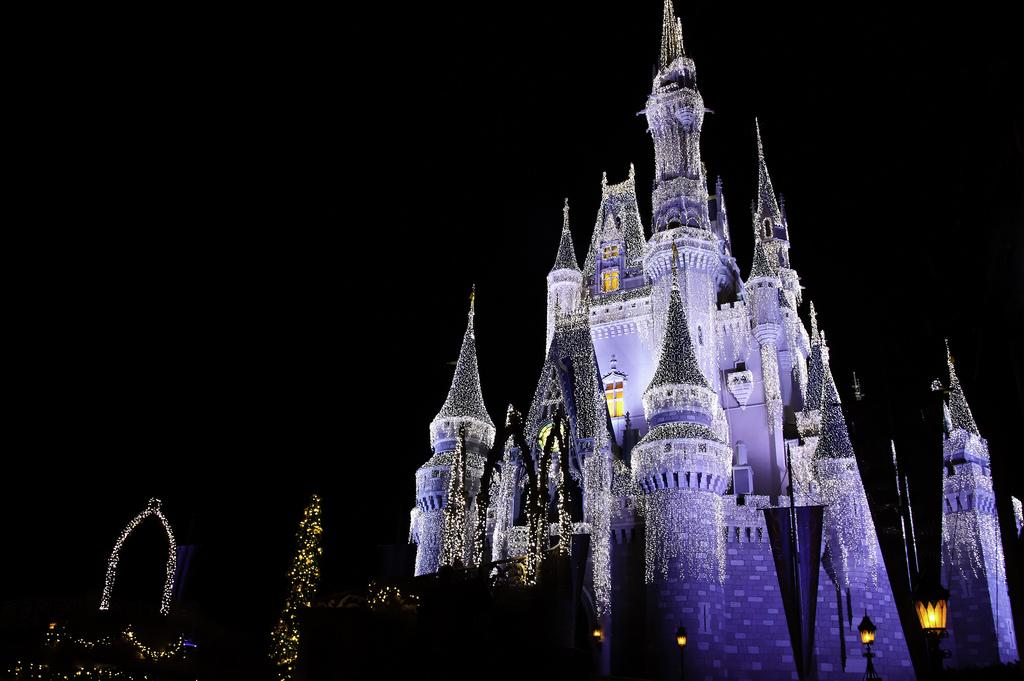What type of structure is present in the image? There is a building in the image. What features can be observed on the building? The building has decorations and lights. What type of pancake is being served at the society meeting in the image? There is no pancake or society meeting present in the image. 